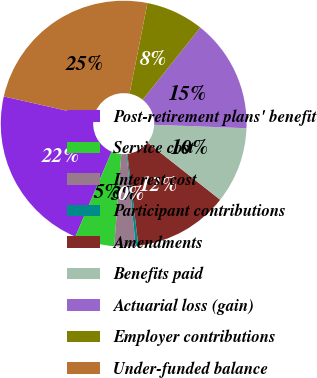Convert chart to OTSL. <chart><loc_0><loc_0><loc_500><loc_500><pie_chart><fcel>Post-retirement plans' benefit<fcel>Service cost<fcel>Interest cost<fcel>Participant contributions<fcel>Amendments<fcel>Benefits paid<fcel>Actuarial loss (gain)<fcel>Employer contributions<fcel>Under-funded balance<nl><fcel>22.13%<fcel>5.2%<fcel>2.78%<fcel>0.36%<fcel>12.46%<fcel>10.04%<fcel>14.88%<fcel>7.62%<fcel>24.55%<nl></chart> 